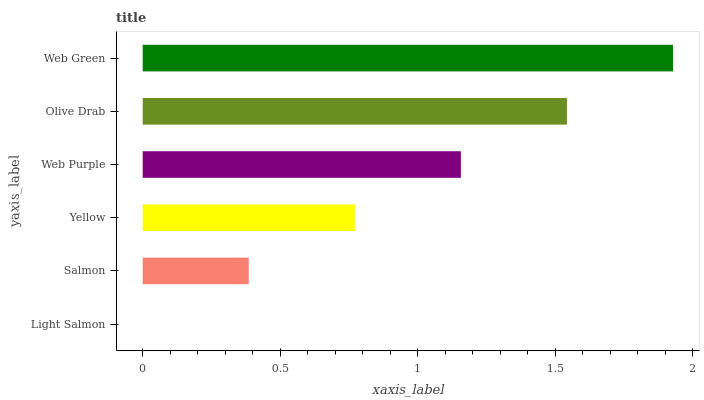Is Light Salmon the minimum?
Answer yes or no. Yes. Is Web Green the maximum?
Answer yes or no. Yes. Is Salmon the minimum?
Answer yes or no. No. Is Salmon the maximum?
Answer yes or no. No. Is Salmon greater than Light Salmon?
Answer yes or no. Yes. Is Light Salmon less than Salmon?
Answer yes or no. Yes. Is Light Salmon greater than Salmon?
Answer yes or no. No. Is Salmon less than Light Salmon?
Answer yes or no. No. Is Web Purple the high median?
Answer yes or no. Yes. Is Yellow the low median?
Answer yes or no. Yes. Is Olive Drab the high median?
Answer yes or no. No. Is Salmon the low median?
Answer yes or no. No. 